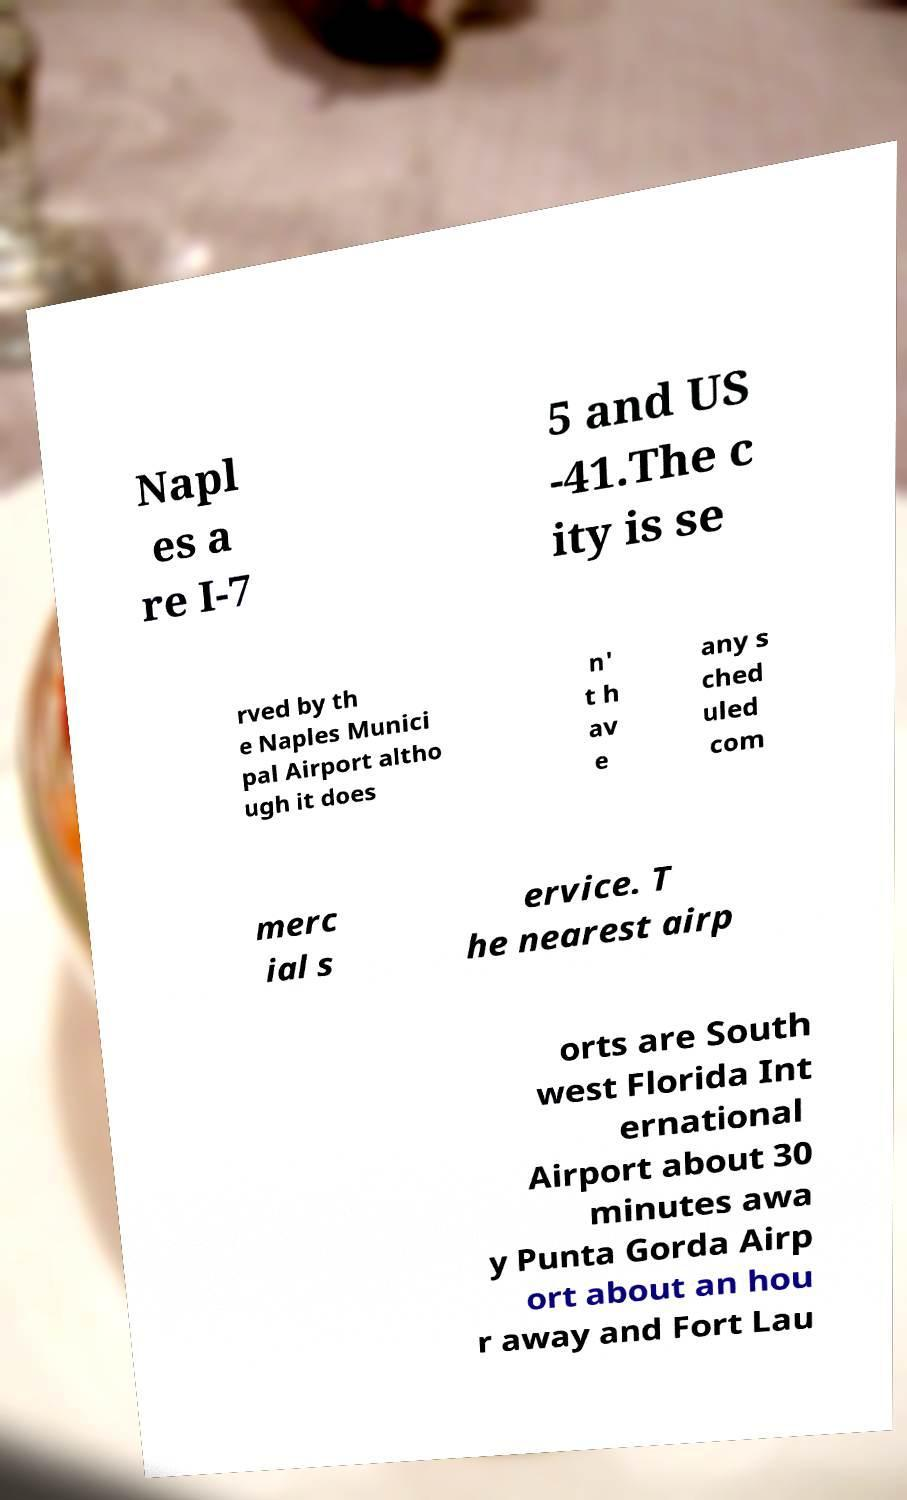I need the written content from this picture converted into text. Can you do that? Napl es a re I-7 5 and US -41.The c ity is se rved by th e Naples Munici pal Airport altho ugh it does n' t h av e any s ched uled com merc ial s ervice. T he nearest airp orts are South west Florida Int ernational Airport about 30 minutes awa y Punta Gorda Airp ort about an hou r away and Fort Lau 